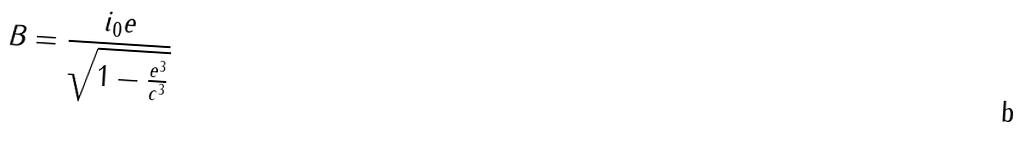Convert formula to latex. <formula><loc_0><loc_0><loc_500><loc_500>B = \frac { i _ { 0 } e } { \sqrt { 1 - \frac { e ^ { 3 } } { c ^ { 3 } } } }</formula> 